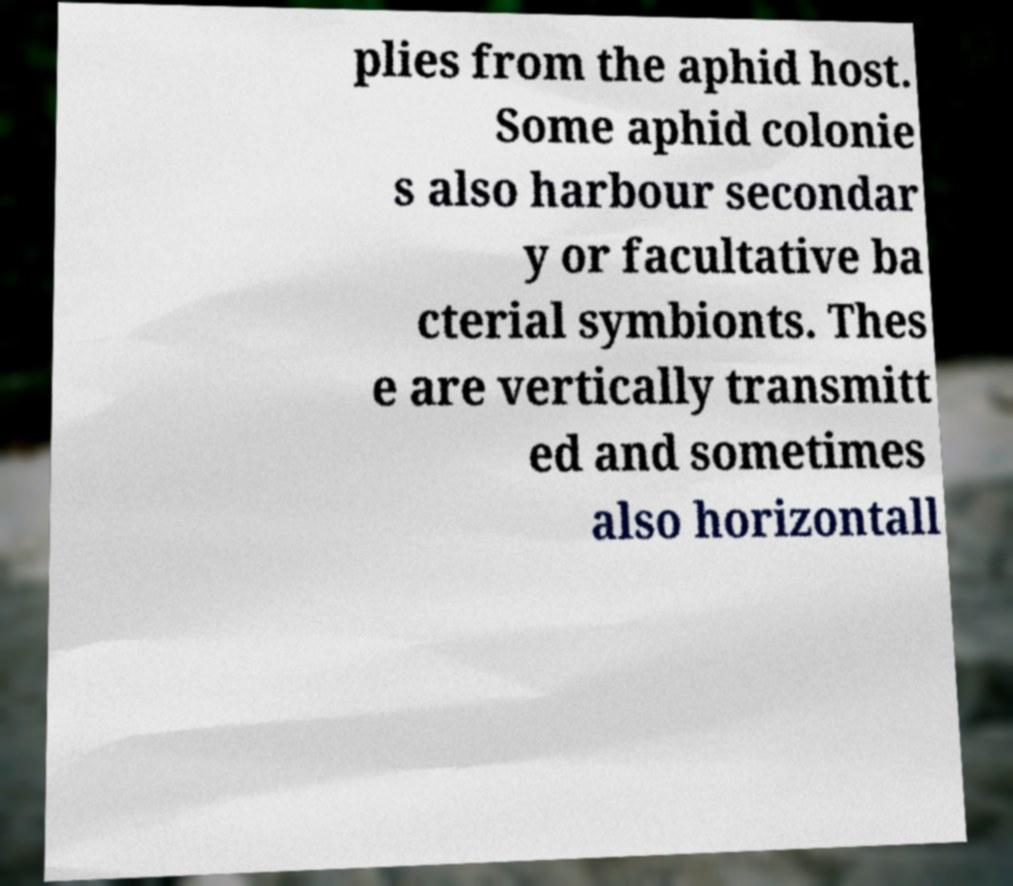Please identify and transcribe the text found in this image. plies from the aphid host. Some aphid colonie s also harbour secondar y or facultative ba cterial symbionts. Thes e are vertically transmitt ed and sometimes also horizontall 